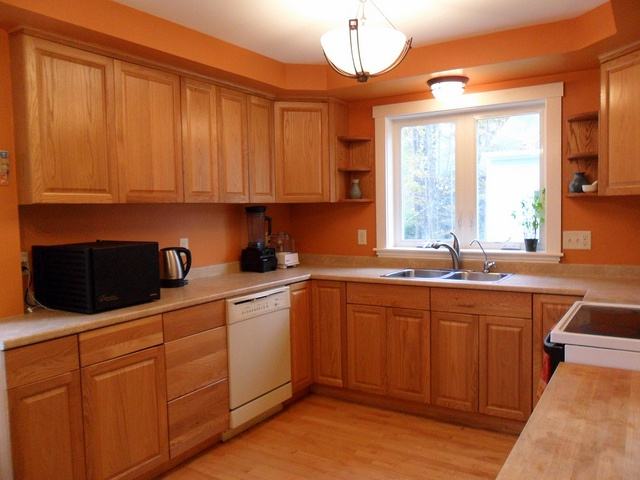Describe the objects in this image and their specific colors. I can see microwave in brown, black, and maroon tones, oven in brown, darkgray, maroon, tan, and black tones, sink in brown, gray, and lavender tones, potted plant in brown, darkgray, white, olive, and lightblue tones, and sink in brown and gray tones in this image. 